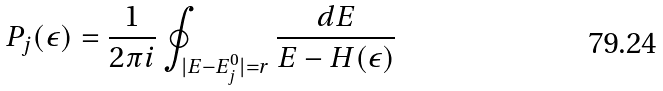Convert formula to latex. <formula><loc_0><loc_0><loc_500><loc_500>P _ { j } ( \epsilon ) = \frac { 1 } { 2 \pi i } \oint _ { | E - E ^ { 0 } _ { j } | = r } \frac { d E } { E - H ( \epsilon ) }</formula> 